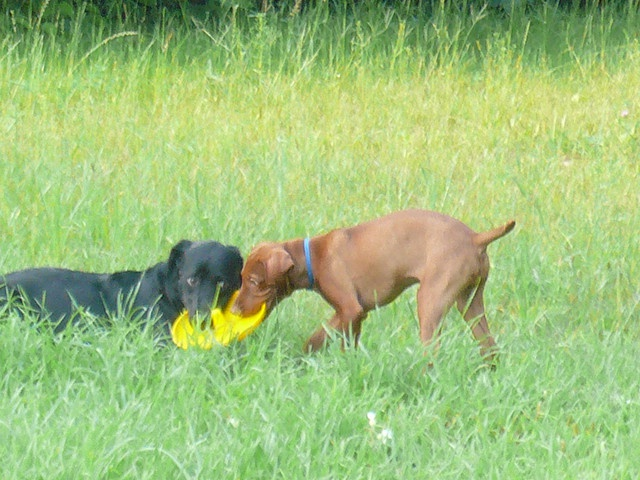Describe the objects in this image and their specific colors. I can see dog in darkgreen, tan, gray, and olive tones, dog in darkgreen, teal, green, and black tones, and frisbee in darkgreen, yellow, khaki, and gold tones in this image. 